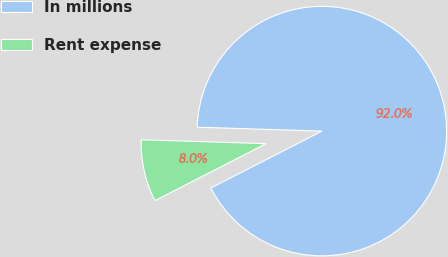<chart> <loc_0><loc_0><loc_500><loc_500><pie_chart><fcel>In millions<fcel>Rent expense<nl><fcel>91.96%<fcel>8.04%<nl></chart> 